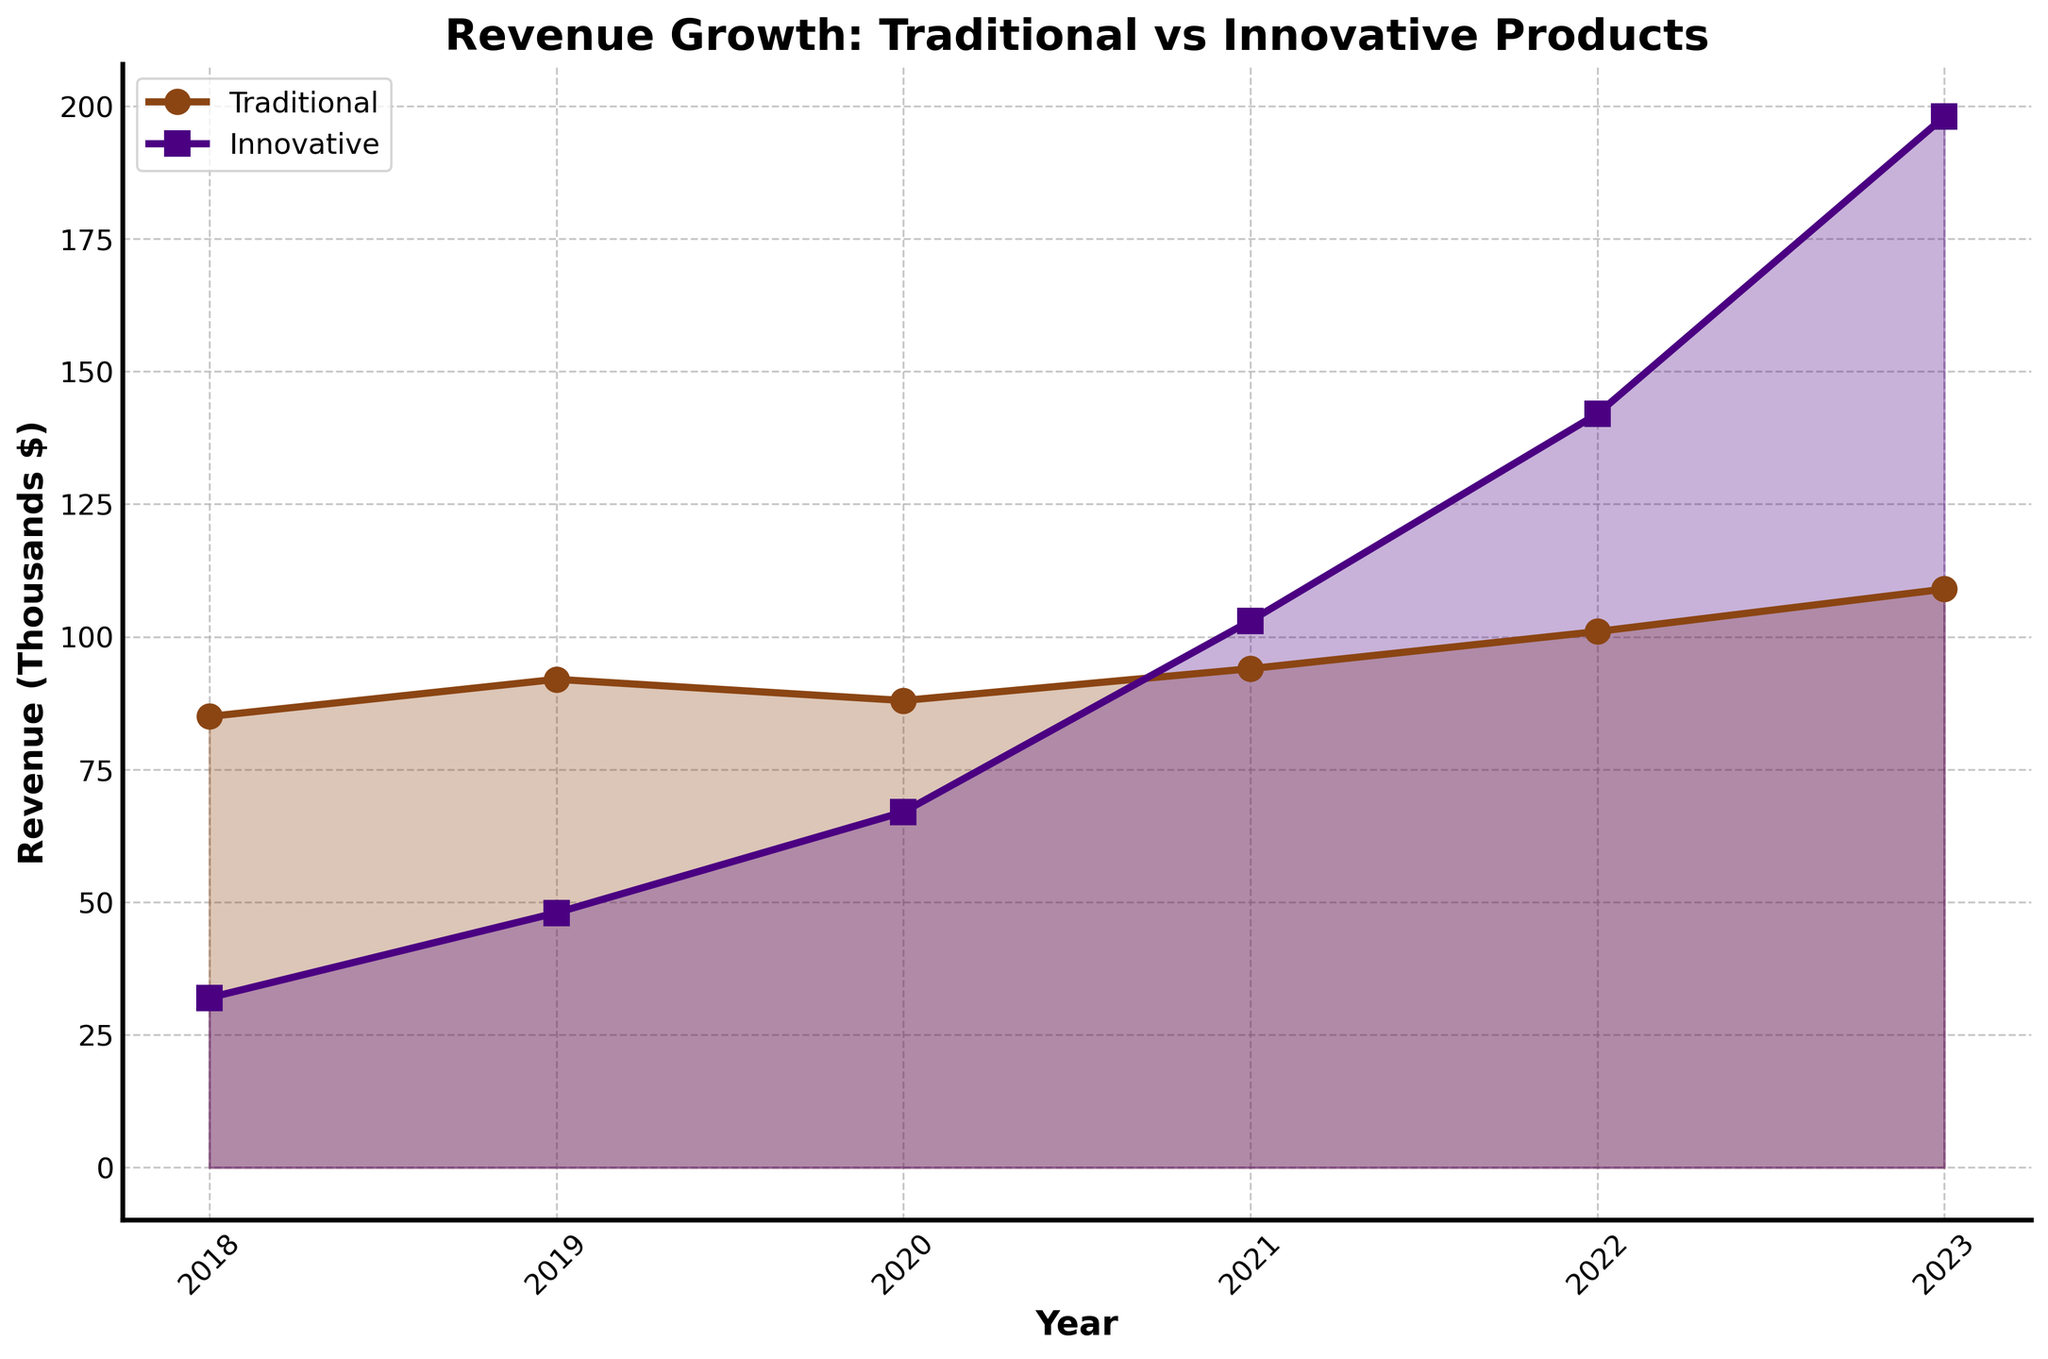What's the average revenue of traditional products over the years? To get the average, sum up the revenue figures for each year (85000+92000+88000+94000+101000+109000) and divide by the number of years (6). The sum is 569000, so the average is 569000 / 6 = 94833.33
Answer: 94833.33 How much more revenue did innovative products generate than traditional products in 2023? Subtract the revenue of traditional products from innovative products for the year 2023. 198000 - 109000 = 89000
Answer: 89000 Which product line had higher revenue in 2020? Compare the revenue of traditional (88000) and innovative (67000) products in the year 2020. Traditional revenue is higher.
Answer: Traditional In which year did innovative products first surpass traditional products in revenue? Identify the year in which the revenue of innovative products first exceeded traditional products by comparing year by year. This occurred in 2021 when innovative (103000) surpassed traditional (94000).
Answer: 2021 What is the overall revenue growth from 2018 to 2023 for traditional products? Subtract the revenue of traditional products in 2018 from that in 2023. 109000 - 85000 = 24000
Answer: 24000 Which year showed the highest growth rate for innovative products? Determine the year with the largest increase in revenue compared to the previous year for innovative products. The largest increase is between 2022 and 2023: 198000 - 142000 = 56000
Answer: 2023 How did the revenue trend for traditional products compare visually to innovative products over the years? Observe the plots for both product lines. Traditional products' revenue shows a more gradual increase while innovative products' revenue increases sharply, especially after 2020.
Answer: Traditional revenue grows gradually while innovative revenue grows sharply What is the combined revenue of both products in 2019? Add the traditional (92000) and innovative (48000) revenues for 2019. 92000 + 48000 = 140000
Answer: 140000 By how much did traditional revenue increase from the first year to the last year? Subtract the revenue of traditional products in 2018 from that in 2023. 109000 - 85000 = 24000
Answer: 24000 Which product line has a darker visual fill color in the plot? Observe the fill colors used for the revenue lines. Traditional products have a brown fill, while innovative products have a blue fill. The blue fill appears darker visually.
Answer: Innovative 